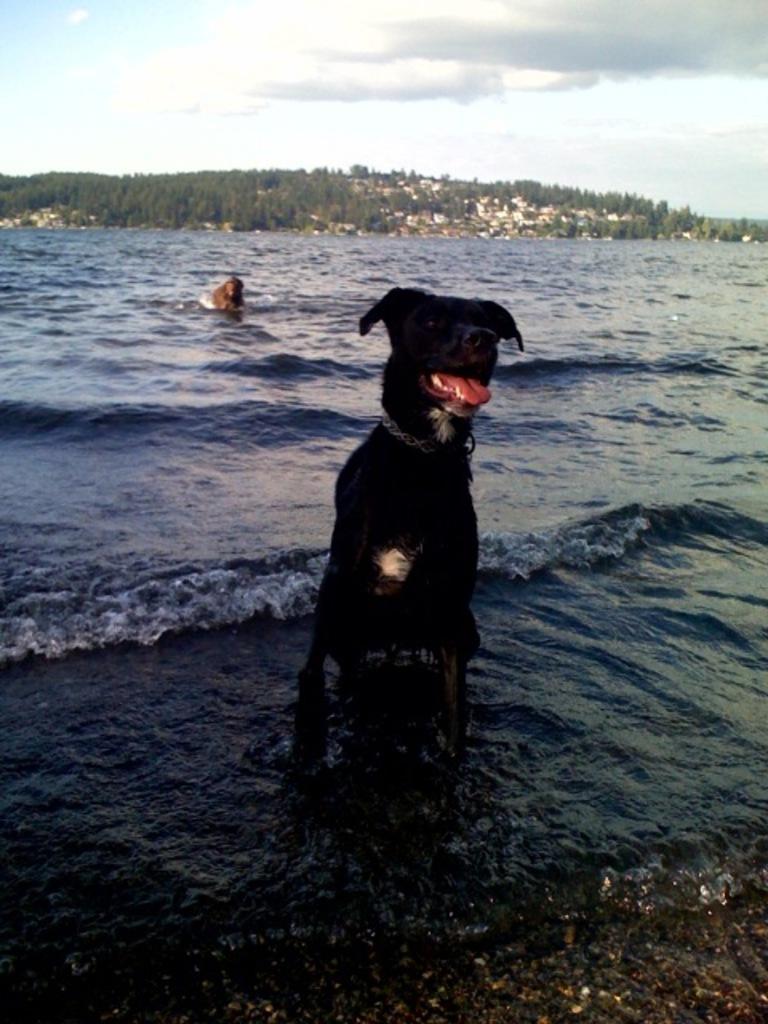How would you summarize this image in a sentence or two? In this picture, in the middle, we can see a dog sitting on the water. On the left side, we can also see another animal. In the background, we can see trees, houses, rocks. At the top, we can see a sky which is cloudy, at the bottom there is a water in an ocean. 